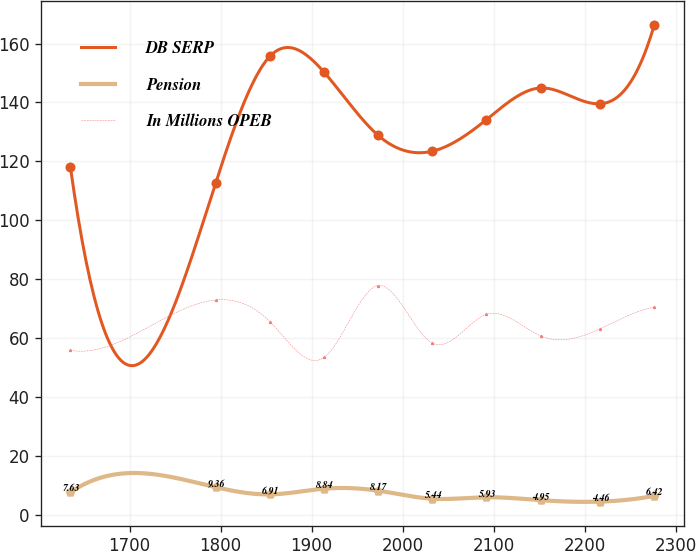Convert chart. <chart><loc_0><loc_0><loc_500><loc_500><line_chart><ecel><fcel>DB SERP<fcel>Pension<fcel>In Millions OPEB<nl><fcel>1635.03<fcel>118.07<fcel>7.63<fcel>55.84<nl><fcel>1794.6<fcel>112.7<fcel>9.36<fcel>72.92<nl><fcel>1854.08<fcel>155.66<fcel>6.91<fcel>65.6<nl><fcel>1913.56<fcel>150.29<fcel>8.84<fcel>53.4<nl><fcel>1973.04<fcel>128.81<fcel>8.17<fcel>77.82<nl><fcel>2032.52<fcel>123.44<fcel>5.44<fcel>58.28<nl><fcel>2092<fcel>134.18<fcel>5.93<fcel>68.04<nl><fcel>2151.48<fcel>144.92<fcel>4.95<fcel>60.72<nl><fcel>2216.92<fcel>139.55<fcel>4.46<fcel>63.16<nl><fcel>2276.4<fcel>166.43<fcel>6.42<fcel>70.48<nl></chart> 